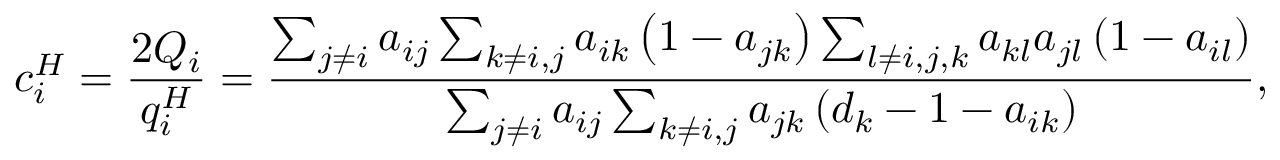<formula> <loc_0><loc_0><loc_500><loc_500>c _ { i } ^ { H } = \frac { 2 Q _ { i } } { q _ { i } ^ { H } } = \frac { \sum _ { j \neq i } a _ { i j } \sum _ { k \neq i , j } a _ { i k } \left ( 1 - a _ { j k } \right ) \sum _ { l \neq i , j , k } a _ { k l } a _ { j l } \left ( 1 - a _ { i l } \right ) } { \sum _ { j \neq i } a _ { i j } \sum _ { k \neq i , j } a _ { j k } \left ( d _ { k } - 1 - a _ { i k } \right ) } ,</formula> 